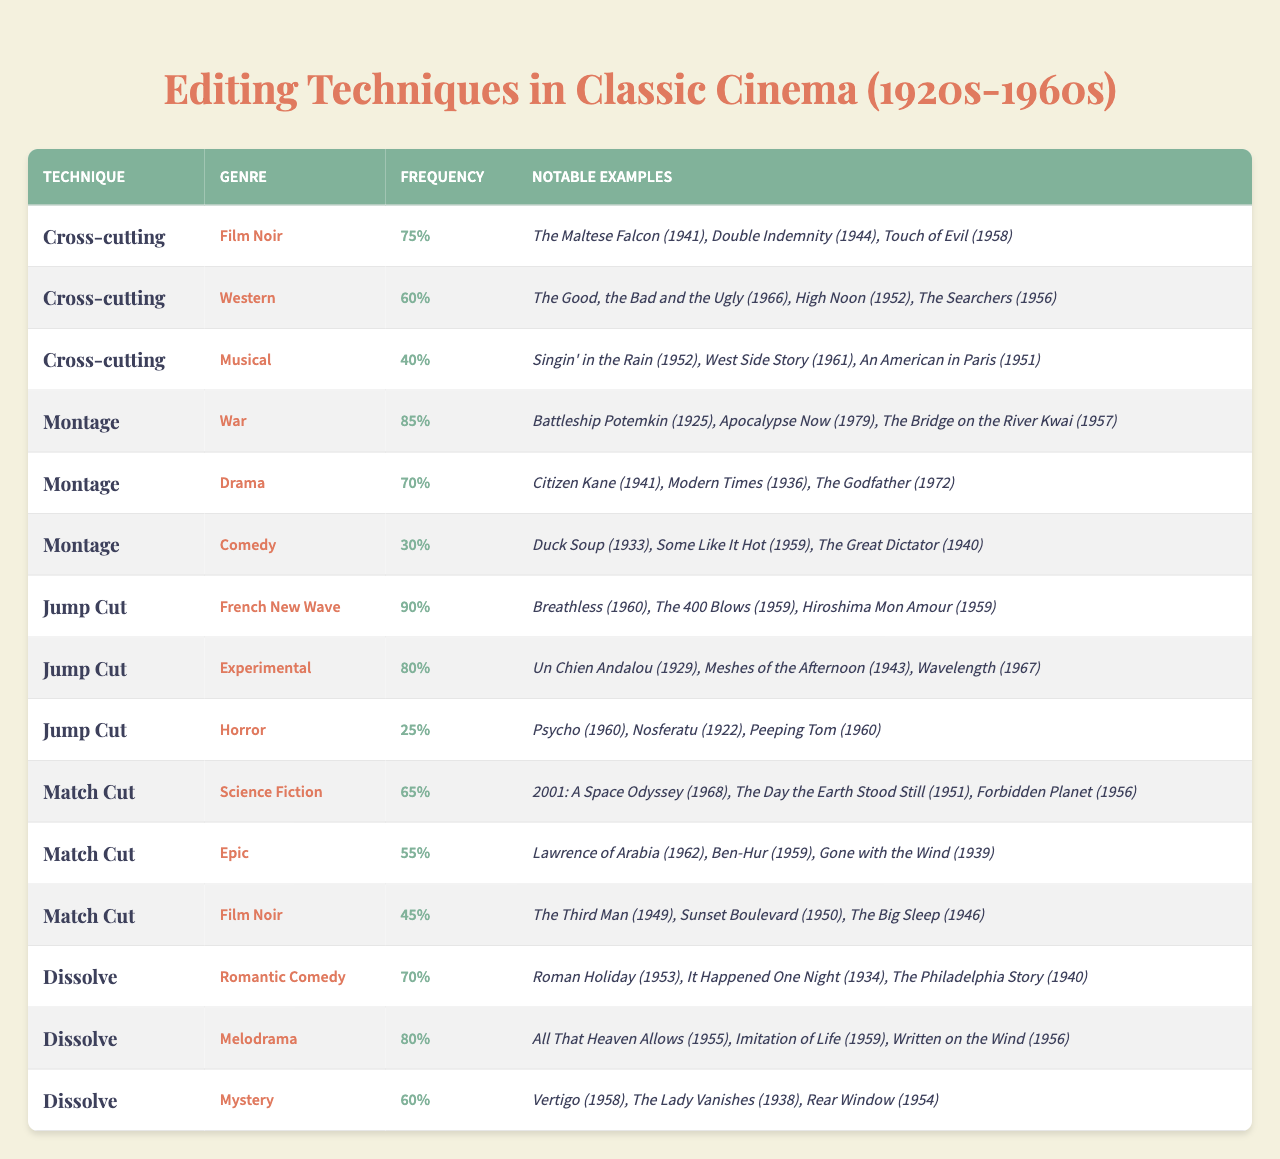What editing technique has the highest frequency in classic cinema? By reviewing the "Frequency" column in the table, the highest frequency is for "Jump Cut," which has a frequency of 90% for the "French New Wave" genre.
Answer: Jump Cut Which genre has the lowest usage of "Dissolve"? Looking at the "Dissolve" technique, the "Mystery" genre has a frequency of 60%, which is lower than "Romantic Comedy" (70%) and "Melodrama" (80%).
Answer: Mystery What is the frequency range of "Montage" used across different genres? The "Montage" technique has a frequency of 30% in "Comedy" (lowest) and 85% in "War" (highest). Therefore, the range is 85 - 30 = 55%.
Answer: 55% How many editing techniques have a frequency of 60% or higher? From the table, we observe the following frequencies: "Cross-cutting" (75% in Film Noir and 60% in Western), "Montage" (85% and 70%), "Jump Cut" (90% and 80%), "Match Cut" (65%), and "Dissolve" (70% and 80%). There are 5 techniques with frequencies 60% or higher.
Answer: 5 If we combine the frequencies of "Match Cut" across its genres, what would be their total frequency? The frequencies for "Match Cut" are 65% (Science Fiction), 55% (Epic), and 45% (Film Noir). Adding these together gives 65 + 55 + 45 = 165%.
Answer: 165% Is the "Horror" genre associated with higher frequency editing techniques compared to "Western"? "Horror" has a frequency of 25% for the "Jump Cut", while "Western" has 60% for "Cross-cutting". Thus, "Western" uses editing techniques with higher frequencies compared to "Horror".
Answer: Yes Which editing technique is most commonly used in the "War" genre? The "War" genre uses "Montage" most frequently, with a frequency of 85%.
Answer: Montage What is the average frequency of "Cross-cutting" across the genres listed? The frequencies for "Cross-cutting" are 75% (Film Noir), 60% (Western), and 40% (Musical). The average is calculated as (75 + 60 + 40)/3 = 58.33%, which can be rounded to 58%.
Answer: 58% Does the "Melodrama" genre have a frequency greater than 70% for any editing technique? Yes, the "Melodrama" genre has a frequency of 80% for the "Dissolve" technique, which is greater than 70%.
Answer: Yes What editing technique has the least notable examples in the table? From the table, the "Horror" genre with the "Jump Cut" technique has the least notable examples listed, only three films.
Answer: Jump Cut 